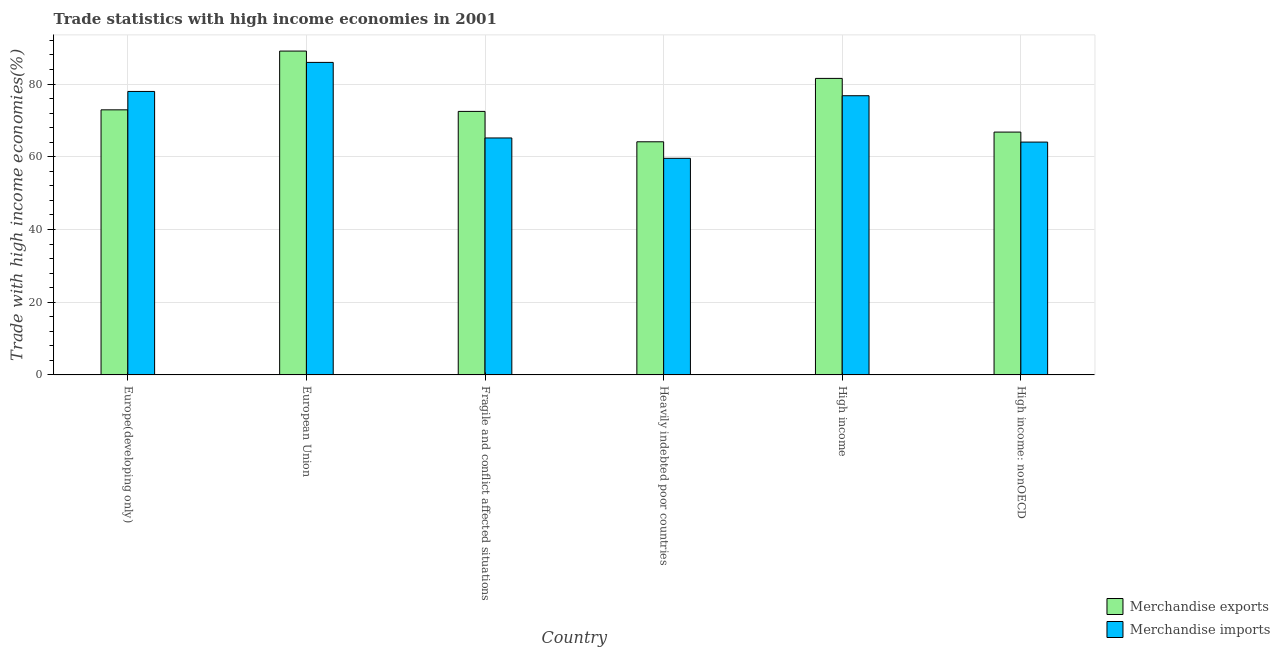How many different coloured bars are there?
Your answer should be compact. 2. How many groups of bars are there?
Give a very brief answer. 6. Are the number of bars on each tick of the X-axis equal?
Keep it short and to the point. Yes. How many bars are there on the 5th tick from the right?
Provide a short and direct response. 2. What is the merchandise imports in Europe(developing only)?
Your response must be concise. 77.96. Across all countries, what is the maximum merchandise imports?
Provide a succinct answer. 85.94. Across all countries, what is the minimum merchandise imports?
Offer a terse response. 59.56. In which country was the merchandise imports minimum?
Provide a succinct answer. Heavily indebted poor countries. What is the total merchandise imports in the graph?
Offer a terse response. 429.43. What is the difference between the merchandise exports in Europe(developing only) and that in Fragile and conflict affected situations?
Offer a terse response. 0.43. What is the difference between the merchandise exports in Europe(developing only) and the merchandise imports in Fragile and conflict affected situations?
Offer a terse response. 7.74. What is the average merchandise exports per country?
Your response must be concise. 74.48. What is the difference between the merchandise imports and merchandise exports in High income?
Make the answer very short. -4.77. In how many countries, is the merchandise imports greater than 52 %?
Offer a terse response. 6. What is the ratio of the merchandise imports in European Union to that in Heavily indebted poor countries?
Give a very brief answer. 1.44. What is the difference between the highest and the second highest merchandise imports?
Offer a terse response. 7.99. What is the difference between the highest and the lowest merchandise exports?
Keep it short and to the point. 24.95. In how many countries, is the merchandise exports greater than the average merchandise exports taken over all countries?
Provide a short and direct response. 2. What does the 1st bar from the left in Heavily indebted poor countries represents?
Give a very brief answer. Merchandise exports. How many bars are there?
Give a very brief answer. 12. Are all the bars in the graph horizontal?
Give a very brief answer. No. How many countries are there in the graph?
Ensure brevity in your answer.  6. What is the difference between two consecutive major ticks on the Y-axis?
Ensure brevity in your answer.  20. Where does the legend appear in the graph?
Your response must be concise. Bottom right. How are the legend labels stacked?
Offer a terse response. Vertical. What is the title of the graph?
Provide a succinct answer. Trade statistics with high income economies in 2001. Does "Personal remittances" appear as one of the legend labels in the graph?
Provide a short and direct response. No. What is the label or title of the X-axis?
Your answer should be compact. Country. What is the label or title of the Y-axis?
Offer a very short reply. Trade with high income economies(%). What is the Trade with high income economies(%) in Merchandise exports in Europe(developing only)?
Offer a very short reply. 72.9. What is the Trade with high income economies(%) in Merchandise imports in Europe(developing only)?
Offer a terse response. 77.96. What is the Trade with high income economies(%) of Merchandise exports in European Union?
Your answer should be very brief. 89.06. What is the Trade with high income economies(%) in Merchandise imports in European Union?
Make the answer very short. 85.94. What is the Trade with high income economies(%) of Merchandise exports in Fragile and conflict affected situations?
Offer a terse response. 72.47. What is the Trade with high income economies(%) of Merchandise imports in Fragile and conflict affected situations?
Offer a very short reply. 65.16. What is the Trade with high income economies(%) in Merchandise exports in Heavily indebted poor countries?
Provide a short and direct response. 64.11. What is the Trade with high income economies(%) in Merchandise imports in Heavily indebted poor countries?
Your answer should be very brief. 59.56. What is the Trade with high income economies(%) in Merchandise exports in High income?
Offer a very short reply. 81.54. What is the Trade with high income economies(%) of Merchandise imports in High income?
Provide a short and direct response. 76.78. What is the Trade with high income economies(%) in Merchandise exports in High income: nonOECD?
Offer a very short reply. 66.78. What is the Trade with high income economies(%) in Merchandise imports in High income: nonOECD?
Your answer should be very brief. 64.03. Across all countries, what is the maximum Trade with high income economies(%) of Merchandise exports?
Provide a short and direct response. 89.06. Across all countries, what is the maximum Trade with high income economies(%) in Merchandise imports?
Your response must be concise. 85.94. Across all countries, what is the minimum Trade with high income economies(%) of Merchandise exports?
Your response must be concise. 64.11. Across all countries, what is the minimum Trade with high income economies(%) of Merchandise imports?
Your answer should be compact. 59.56. What is the total Trade with high income economies(%) in Merchandise exports in the graph?
Make the answer very short. 446.85. What is the total Trade with high income economies(%) in Merchandise imports in the graph?
Your response must be concise. 429.43. What is the difference between the Trade with high income economies(%) in Merchandise exports in Europe(developing only) and that in European Union?
Give a very brief answer. -16.16. What is the difference between the Trade with high income economies(%) of Merchandise imports in Europe(developing only) and that in European Union?
Provide a succinct answer. -7.99. What is the difference between the Trade with high income economies(%) of Merchandise exports in Europe(developing only) and that in Fragile and conflict affected situations?
Your response must be concise. 0.43. What is the difference between the Trade with high income economies(%) in Merchandise imports in Europe(developing only) and that in Fragile and conflict affected situations?
Your response must be concise. 12.79. What is the difference between the Trade with high income economies(%) in Merchandise exports in Europe(developing only) and that in Heavily indebted poor countries?
Your answer should be compact. 8.79. What is the difference between the Trade with high income economies(%) in Merchandise imports in Europe(developing only) and that in Heavily indebted poor countries?
Provide a short and direct response. 18.39. What is the difference between the Trade with high income economies(%) of Merchandise exports in Europe(developing only) and that in High income?
Offer a very short reply. -8.64. What is the difference between the Trade with high income economies(%) of Merchandise imports in Europe(developing only) and that in High income?
Keep it short and to the point. 1.18. What is the difference between the Trade with high income economies(%) in Merchandise exports in Europe(developing only) and that in High income: nonOECD?
Ensure brevity in your answer.  6.12. What is the difference between the Trade with high income economies(%) in Merchandise imports in Europe(developing only) and that in High income: nonOECD?
Provide a succinct answer. 13.93. What is the difference between the Trade with high income economies(%) in Merchandise exports in European Union and that in Fragile and conflict affected situations?
Offer a very short reply. 16.59. What is the difference between the Trade with high income economies(%) of Merchandise imports in European Union and that in Fragile and conflict affected situations?
Your answer should be compact. 20.78. What is the difference between the Trade with high income economies(%) of Merchandise exports in European Union and that in Heavily indebted poor countries?
Your response must be concise. 24.95. What is the difference between the Trade with high income economies(%) in Merchandise imports in European Union and that in Heavily indebted poor countries?
Offer a very short reply. 26.38. What is the difference between the Trade with high income economies(%) of Merchandise exports in European Union and that in High income?
Your response must be concise. 7.52. What is the difference between the Trade with high income economies(%) of Merchandise imports in European Union and that in High income?
Offer a very short reply. 9.17. What is the difference between the Trade with high income economies(%) in Merchandise exports in European Union and that in High income: nonOECD?
Make the answer very short. 22.28. What is the difference between the Trade with high income economies(%) of Merchandise imports in European Union and that in High income: nonOECD?
Provide a succinct answer. 21.91. What is the difference between the Trade with high income economies(%) in Merchandise exports in Fragile and conflict affected situations and that in Heavily indebted poor countries?
Make the answer very short. 8.36. What is the difference between the Trade with high income economies(%) of Merchandise imports in Fragile and conflict affected situations and that in Heavily indebted poor countries?
Your answer should be compact. 5.6. What is the difference between the Trade with high income economies(%) in Merchandise exports in Fragile and conflict affected situations and that in High income?
Make the answer very short. -9.07. What is the difference between the Trade with high income economies(%) in Merchandise imports in Fragile and conflict affected situations and that in High income?
Offer a very short reply. -11.61. What is the difference between the Trade with high income economies(%) in Merchandise exports in Fragile and conflict affected situations and that in High income: nonOECD?
Provide a short and direct response. 5.69. What is the difference between the Trade with high income economies(%) in Merchandise imports in Fragile and conflict affected situations and that in High income: nonOECD?
Provide a short and direct response. 1.13. What is the difference between the Trade with high income economies(%) in Merchandise exports in Heavily indebted poor countries and that in High income?
Offer a terse response. -17.43. What is the difference between the Trade with high income economies(%) of Merchandise imports in Heavily indebted poor countries and that in High income?
Provide a short and direct response. -17.21. What is the difference between the Trade with high income economies(%) in Merchandise exports in Heavily indebted poor countries and that in High income: nonOECD?
Provide a short and direct response. -2.67. What is the difference between the Trade with high income economies(%) in Merchandise imports in Heavily indebted poor countries and that in High income: nonOECD?
Offer a terse response. -4.47. What is the difference between the Trade with high income economies(%) in Merchandise exports in High income and that in High income: nonOECD?
Your answer should be very brief. 14.76. What is the difference between the Trade with high income economies(%) of Merchandise imports in High income and that in High income: nonOECD?
Your answer should be compact. 12.75. What is the difference between the Trade with high income economies(%) of Merchandise exports in Europe(developing only) and the Trade with high income economies(%) of Merchandise imports in European Union?
Provide a short and direct response. -13.04. What is the difference between the Trade with high income economies(%) in Merchandise exports in Europe(developing only) and the Trade with high income economies(%) in Merchandise imports in Fragile and conflict affected situations?
Provide a short and direct response. 7.74. What is the difference between the Trade with high income economies(%) of Merchandise exports in Europe(developing only) and the Trade with high income economies(%) of Merchandise imports in Heavily indebted poor countries?
Provide a succinct answer. 13.33. What is the difference between the Trade with high income economies(%) of Merchandise exports in Europe(developing only) and the Trade with high income economies(%) of Merchandise imports in High income?
Offer a very short reply. -3.88. What is the difference between the Trade with high income economies(%) in Merchandise exports in Europe(developing only) and the Trade with high income economies(%) in Merchandise imports in High income: nonOECD?
Provide a succinct answer. 8.87. What is the difference between the Trade with high income economies(%) in Merchandise exports in European Union and the Trade with high income economies(%) in Merchandise imports in Fragile and conflict affected situations?
Offer a terse response. 23.9. What is the difference between the Trade with high income economies(%) in Merchandise exports in European Union and the Trade with high income economies(%) in Merchandise imports in Heavily indebted poor countries?
Make the answer very short. 29.5. What is the difference between the Trade with high income economies(%) of Merchandise exports in European Union and the Trade with high income economies(%) of Merchandise imports in High income?
Your answer should be compact. 12.28. What is the difference between the Trade with high income economies(%) in Merchandise exports in European Union and the Trade with high income economies(%) in Merchandise imports in High income: nonOECD?
Keep it short and to the point. 25.03. What is the difference between the Trade with high income economies(%) in Merchandise exports in Fragile and conflict affected situations and the Trade with high income economies(%) in Merchandise imports in Heavily indebted poor countries?
Your answer should be compact. 12.9. What is the difference between the Trade with high income economies(%) in Merchandise exports in Fragile and conflict affected situations and the Trade with high income economies(%) in Merchandise imports in High income?
Provide a succinct answer. -4.31. What is the difference between the Trade with high income economies(%) in Merchandise exports in Fragile and conflict affected situations and the Trade with high income economies(%) in Merchandise imports in High income: nonOECD?
Keep it short and to the point. 8.44. What is the difference between the Trade with high income economies(%) in Merchandise exports in Heavily indebted poor countries and the Trade with high income economies(%) in Merchandise imports in High income?
Keep it short and to the point. -12.67. What is the difference between the Trade with high income economies(%) in Merchandise exports in Heavily indebted poor countries and the Trade with high income economies(%) in Merchandise imports in High income: nonOECD?
Your response must be concise. 0.08. What is the difference between the Trade with high income economies(%) in Merchandise exports in High income and the Trade with high income economies(%) in Merchandise imports in High income: nonOECD?
Provide a succinct answer. 17.51. What is the average Trade with high income economies(%) of Merchandise exports per country?
Give a very brief answer. 74.48. What is the average Trade with high income economies(%) of Merchandise imports per country?
Offer a very short reply. 71.57. What is the difference between the Trade with high income economies(%) of Merchandise exports and Trade with high income economies(%) of Merchandise imports in Europe(developing only)?
Provide a succinct answer. -5.06. What is the difference between the Trade with high income economies(%) in Merchandise exports and Trade with high income economies(%) in Merchandise imports in European Union?
Provide a short and direct response. 3.12. What is the difference between the Trade with high income economies(%) of Merchandise exports and Trade with high income economies(%) of Merchandise imports in Fragile and conflict affected situations?
Your response must be concise. 7.31. What is the difference between the Trade with high income economies(%) of Merchandise exports and Trade with high income economies(%) of Merchandise imports in Heavily indebted poor countries?
Make the answer very short. 4.54. What is the difference between the Trade with high income economies(%) in Merchandise exports and Trade with high income economies(%) in Merchandise imports in High income?
Ensure brevity in your answer.  4.77. What is the difference between the Trade with high income economies(%) in Merchandise exports and Trade with high income economies(%) in Merchandise imports in High income: nonOECD?
Offer a very short reply. 2.75. What is the ratio of the Trade with high income economies(%) in Merchandise exports in Europe(developing only) to that in European Union?
Give a very brief answer. 0.82. What is the ratio of the Trade with high income economies(%) of Merchandise imports in Europe(developing only) to that in European Union?
Provide a short and direct response. 0.91. What is the ratio of the Trade with high income economies(%) in Merchandise exports in Europe(developing only) to that in Fragile and conflict affected situations?
Your answer should be very brief. 1.01. What is the ratio of the Trade with high income economies(%) of Merchandise imports in Europe(developing only) to that in Fragile and conflict affected situations?
Offer a terse response. 1.2. What is the ratio of the Trade with high income economies(%) of Merchandise exports in Europe(developing only) to that in Heavily indebted poor countries?
Provide a short and direct response. 1.14. What is the ratio of the Trade with high income economies(%) of Merchandise imports in Europe(developing only) to that in Heavily indebted poor countries?
Give a very brief answer. 1.31. What is the ratio of the Trade with high income economies(%) of Merchandise exports in Europe(developing only) to that in High income?
Give a very brief answer. 0.89. What is the ratio of the Trade with high income economies(%) in Merchandise imports in Europe(developing only) to that in High income?
Your response must be concise. 1.02. What is the ratio of the Trade with high income economies(%) of Merchandise exports in Europe(developing only) to that in High income: nonOECD?
Provide a succinct answer. 1.09. What is the ratio of the Trade with high income economies(%) in Merchandise imports in Europe(developing only) to that in High income: nonOECD?
Provide a succinct answer. 1.22. What is the ratio of the Trade with high income economies(%) in Merchandise exports in European Union to that in Fragile and conflict affected situations?
Ensure brevity in your answer.  1.23. What is the ratio of the Trade with high income economies(%) in Merchandise imports in European Union to that in Fragile and conflict affected situations?
Provide a short and direct response. 1.32. What is the ratio of the Trade with high income economies(%) in Merchandise exports in European Union to that in Heavily indebted poor countries?
Give a very brief answer. 1.39. What is the ratio of the Trade with high income economies(%) in Merchandise imports in European Union to that in Heavily indebted poor countries?
Make the answer very short. 1.44. What is the ratio of the Trade with high income economies(%) in Merchandise exports in European Union to that in High income?
Your answer should be compact. 1.09. What is the ratio of the Trade with high income economies(%) in Merchandise imports in European Union to that in High income?
Your answer should be very brief. 1.12. What is the ratio of the Trade with high income economies(%) in Merchandise exports in European Union to that in High income: nonOECD?
Ensure brevity in your answer.  1.33. What is the ratio of the Trade with high income economies(%) in Merchandise imports in European Union to that in High income: nonOECD?
Offer a very short reply. 1.34. What is the ratio of the Trade with high income economies(%) of Merchandise exports in Fragile and conflict affected situations to that in Heavily indebted poor countries?
Give a very brief answer. 1.13. What is the ratio of the Trade with high income economies(%) of Merchandise imports in Fragile and conflict affected situations to that in Heavily indebted poor countries?
Give a very brief answer. 1.09. What is the ratio of the Trade with high income economies(%) of Merchandise exports in Fragile and conflict affected situations to that in High income?
Your answer should be compact. 0.89. What is the ratio of the Trade with high income economies(%) of Merchandise imports in Fragile and conflict affected situations to that in High income?
Your response must be concise. 0.85. What is the ratio of the Trade with high income economies(%) in Merchandise exports in Fragile and conflict affected situations to that in High income: nonOECD?
Keep it short and to the point. 1.09. What is the ratio of the Trade with high income economies(%) in Merchandise imports in Fragile and conflict affected situations to that in High income: nonOECD?
Your answer should be compact. 1.02. What is the ratio of the Trade with high income economies(%) of Merchandise exports in Heavily indebted poor countries to that in High income?
Ensure brevity in your answer.  0.79. What is the ratio of the Trade with high income economies(%) in Merchandise imports in Heavily indebted poor countries to that in High income?
Provide a succinct answer. 0.78. What is the ratio of the Trade with high income economies(%) of Merchandise imports in Heavily indebted poor countries to that in High income: nonOECD?
Offer a very short reply. 0.93. What is the ratio of the Trade with high income economies(%) in Merchandise exports in High income to that in High income: nonOECD?
Offer a very short reply. 1.22. What is the ratio of the Trade with high income economies(%) of Merchandise imports in High income to that in High income: nonOECD?
Make the answer very short. 1.2. What is the difference between the highest and the second highest Trade with high income economies(%) of Merchandise exports?
Make the answer very short. 7.52. What is the difference between the highest and the second highest Trade with high income economies(%) of Merchandise imports?
Your response must be concise. 7.99. What is the difference between the highest and the lowest Trade with high income economies(%) of Merchandise exports?
Offer a terse response. 24.95. What is the difference between the highest and the lowest Trade with high income economies(%) of Merchandise imports?
Your answer should be very brief. 26.38. 